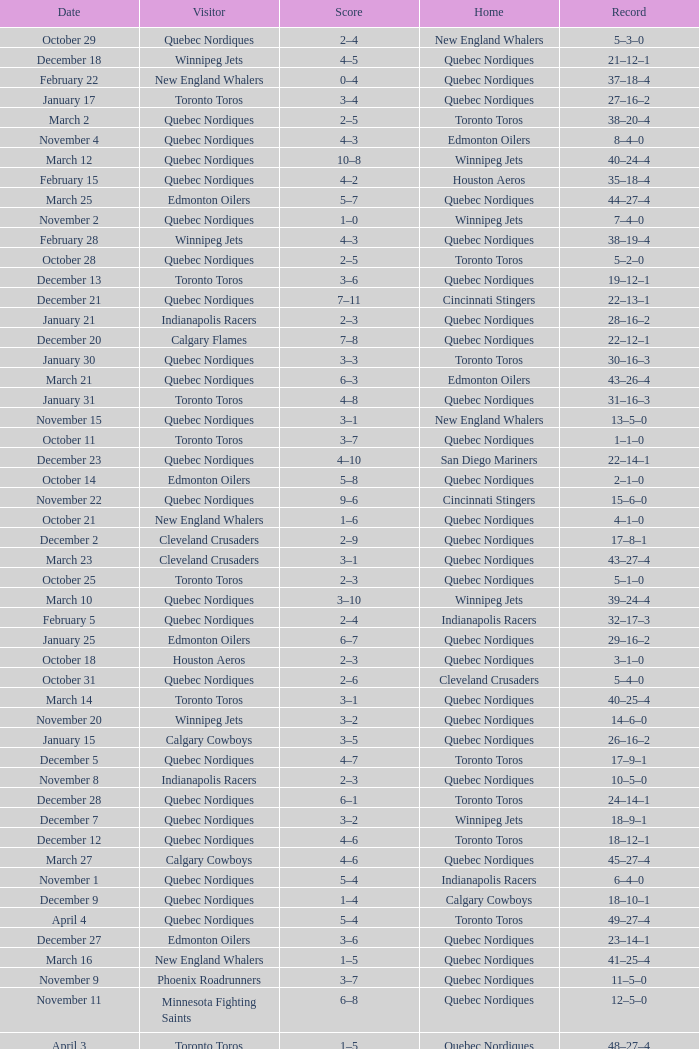What was the date of the game with a score of 2–1? November 30. Would you be able to parse every entry in this table? {'header': ['Date', 'Visitor', 'Score', 'Home', 'Record'], 'rows': [['October 29', 'Quebec Nordiques', '2–4', 'New England Whalers', '5–3–0'], ['December 18', 'Winnipeg Jets', '4–5', 'Quebec Nordiques', '21–12–1'], ['February 22', 'New England Whalers', '0–4', 'Quebec Nordiques', '37–18–4'], ['January 17', 'Toronto Toros', '3–4', 'Quebec Nordiques', '27–16–2'], ['March 2', 'Quebec Nordiques', '2–5', 'Toronto Toros', '38–20–4'], ['November 4', 'Quebec Nordiques', '4–3', 'Edmonton Oilers', '8–4–0'], ['March 12', 'Quebec Nordiques', '10–8', 'Winnipeg Jets', '40–24–4'], ['February 15', 'Quebec Nordiques', '4–2', 'Houston Aeros', '35–18–4'], ['March 25', 'Edmonton Oilers', '5–7', 'Quebec Nordiques', '44–27–4'], ['November 2', 'Quebec Nordiques', '1–0', 'Winnipeg Jets', '7–4–0'], ['February 28', 'Winnipeg Jets', '4–3', 'Quebec Nordiques', '38–19–4'], ['October 28', 'Quebec Nordiques', '2–5', 'Toronto Toros', '5–2–0'], ['December 13', 'Toronto Toros', '3–6', 'Quebec Nordiques', '19–12–1'], ['December 21', 'Quebec Nordiques', '7–11', 'Cincinnati Stingers', '22–13–1'], ['January 21', 'Indianapolis Racers', '2–3', 'Quebec Nordiques', '28–16–2'], ['December 20', 'Calgary Flames', '7–8', 'Quebec Nordiques', '22–12–1'], ['January 30', 'Quebec Nordiques', '3–3', 'Toronto Toros', '30–16–3'], ['March 21', 'Quebec Nordiques', '6–3', 'Edmonton Oilers', '43–26–4'], ['January 31', 'Toronto Toros', '4–8', 'Quebec Nordiques', '31–16–3'], ['November 15', 'Quebec Nordiques', '3–1', 'New England Whalers', '13–5–0'], ['October 11', 'Toronto Toros', '3–7', 'Quebec Nordiques', '1–1–0'], ['December 23', 'Quebec Nordiques', '4–10', 'San Diego Mariners', '22–14–1'], ['October 14', 'Edmonton Oilers', '5–8', 'Quebec Nordiques', '2–1–0'], ['November 22', 'Quebec Nordiques', '9–6', 'Cincinnati Stingers', '15–6–0'], ['October 21', 'New England Whalers', '1–6', 'Quebec Nordiques', '4–1–0'], ['December 2', 'Cleveland Crusaders', '2–9', 'Quebec Nordiques', '17–8–1'], ['March 23', 'Cleveland Crusaders', '3–1', 'Quebec Nordiques', '43–27–4'], ['October 25', 'Toronto Toros', '2–3', 'Quebec Nordiques', '5–1–0'], ['March 10', 'Quebec Nordiques', '3–10', 'Winnipeg Jets', '39–24–4'], ['February 5', 'Quebec Nordiques', '2–4', 'Indianapolis Racers', '32–17–3'], ['January 25', 'Edmonton Oilers', '6–7', 'Quebec Nordiques', '29–16–2'], ['October 18', 'Houston Aeros', '2–3', 'Quebec Nordiques', '3–1–0'], ['October 31', 'Quebec Nordiques', '2–6', 'Cleveland Crusaders', '5–4–0'], ['March 14', 'Toronto Toros', '3–1', 'Quebec Nordiques', '40–25–4'], ['November 20', 'Winnipeg Jets', '3–2', 'Quebec Nordiques', '14–6–0'], ['January 15', 'Calgary Cowboys', '3–5', 'Quebec Nordiques', '26–16–2'], ['December 5', 'Quebec Nordiques', '4–7', 'Toronto Toros', '17–9–1'], ['November 8', 'Indianapolis Racers', '2–3', 'Quebec Nordiques', '10–5–0'], ['December 28', 'Quebec Nordiques', '6–1', 'Toronto Toros', '24–14–1'], ['December 7', 'Quebec Nordiques', '3–2', 'Winnipeg Jets', '18–9–1'], ['December 12', 'Quebec Nordiques', '4–6', 'Toronto Toros', '18–12–1'], ['March 27', 'Calgary Cowboys', '4–6', 'Quebec Nordiques', '45–27–4'], ['November 1', 'Quebec Nordiques', '5–4', 'Indianapolis Racers', '6–4–0'], ['December 9', 'Quebec Nordiques', '1–4', 'Calgary Cowboys', '18–10–1'], ['April 4', 'Quebec Nordiques', '5–4', 'Toronto Toros', '49–27–4'], ['December 27', 'Edmonton Oilers', '3–6', 'Quebec Nordiques', '23–14–1'], ['March 16', 'New England Whalers', '1–5', 'Quebec Nordiques', '41–25–4'], ['November 9', 'Phoenix Roadrunners', '3–7', 'Quebec Nordiques', '11–5–0'], ['November 11', 'Minnesota Fighting Saints', '6–8', 'Quebec Nordiques', '12–5–0'], ['April 3', 'Toronto Toros', '1–5', 'Quebec Nordiques', '48–27–4'], ['November 23', 'Quebec Nordiques', '0–4', 'Houston Aeros', '15–7–0'], ['February 24', 'Houston Aeros', '1–4', 'Quebec Nordiques', '38–18–4'], ['January 2', 'Quebec Nordiques', '4–5', 'Cleveland Crusaders', '24–15–2'], ['March 30', 'Edmonton Oilers', '3–8', 'Quebec Nordiques', '46–27–4'], ['February 7', 'Quebec Nordiques', '4–4', 'Calgary Cowboys', '32–17–4'], ['November 18', 'Cincinnati Stingers', '4–6', 'Quebec Nordiques', '14–5–0'], ['October 9', 'Winnipeg Jets', '5–3', 'Quebec Nordiques', '0–1–0'], ['April 6', 'Toronto Toros', '6–10', 'Quebec Nordiques', '50–27–4'], ['January 10', 'San Diego Mariners', '3–4', 'Quebec Nordiques', '25–16–2'], ['March 7', 'Quebec Nordiques', '2–4', 'Edmonton Oilers', '39–22–4'], ['January 3', 'Phoenix Roadrunners', '4–1', 'Quebec Nordiques', '24–16–2'], ['November 6', 'Quebec Nordiques', '5–3', 'Denver Spurs', '9–5–0'], ['November 5', 'Quebec Nordiques', '2–4', 'Calgary Cowboys', '8–5–0'], ['February 11', 'Quebec Nordiques', '6–4', 'Winnipeg Jets', '34–17–4'], ['November 27', 'Quebec Nordiques', '1–5', 'San Diego Mariners', '15–8–0'], ['February 8', 'Quebec Nordiques', '5–4', 'Edmonton Oilers', '33–17–4'], ['November 30', 'Quebec Nordiques', '2–1', 'Phoenix Roadrunners', '16–8–1'], ['March 5', 'Quebec Nordiques', '5–4', 'Edmonton Oilers', '39–21–4'], ['February 12', 'Quebec Nordiques', '4–6', 'Minnesota Fighting Saints', '34–18–4'], ['March 19', 'Quebec Nordiques', '4–3', 'Toronto Toros', '42–25–4'], ['February 17', 'San Diego Mariners', '2–5', 'Quebec Nordiques', '36–18–4'], ['November 29', 'Quebec Nordiques', '4–4', 'Phoenix Roadrunners', '15–8–1'], ['December 10', 'Quebec Nordiques', '4–7', 'Edmonton Oilers', '18–11–1'], ['December 16', 'Calgary Cowboys', '3–7', 'Quebec Nordiques', '20–12–1'], ['March 4', 'Quebec Nordiques', '1–4', 'Calgary Cowboys', '38–21–4'], ['February 3', 'Winnipeg Jets', '4–5', 'Quebec Nordiques', '32–16–3'], ['March 9', 'Quebec Nordiques', '4–7', 'Calgary Cowboys', '39–23–4'], ['March 20', 'Calgary Cowboys', '8–7', 'Quebec Nordiques', '42–26–4'], ['December 30', 'Quebec Nordiques', '4–4', 'Minnesota Fighting Saints', '24–14–2'], ['January 27', 'Cincinnati Stingers', '1–9', 'Quebec Nordiques', '30–16–2'], ['April 1', 'Edmonton Oilers', '2–7', 'Quebec Nordiques', '47–27–4']]} 